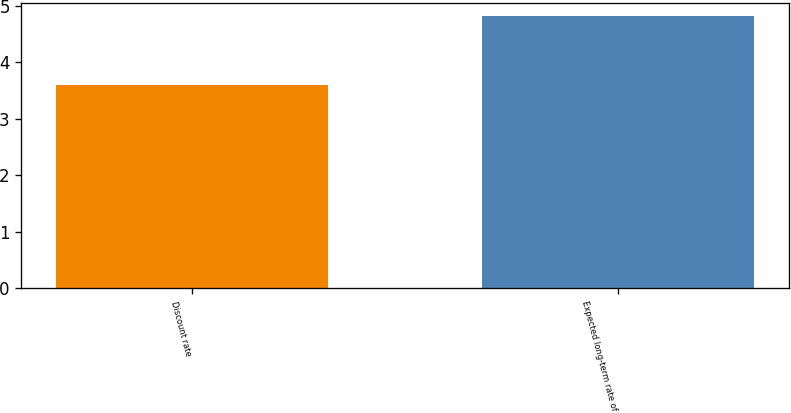<chart> <loc_0><loc_0><loc_500><loc_500><bar_chart><fcel>Discount rate<fcel>Expected long-term rate of<nl><fcel>3.6<fcel>4.81<nl></chart> 